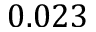<formula> <loc_0><loc_0><loc_500><loc_500>0 . 0 2 3</formula> 